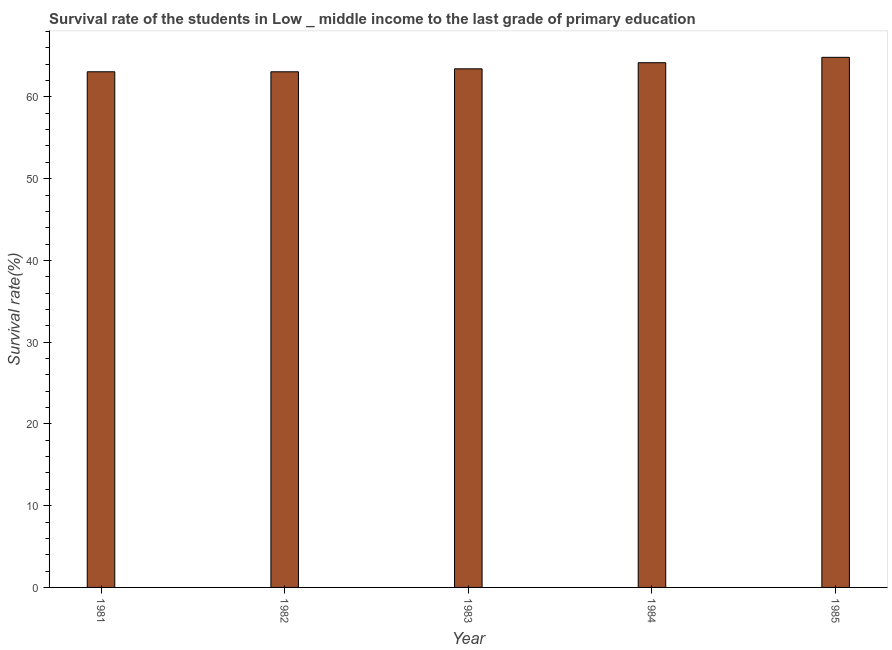Does the graph contain grids?
Offer a very short reply. No. What is the title of the graph?
Make the answer very short. Survival rate of the students in Low _ middle income to the last grade of primary education. What is the label or title of the Y-axis?
Your answer should be compact. Survival rate(%). What is the survival rate in primary education in 1982?
Make the answer very short. 63.07. Across all years, what is the maximum survival rate in primary education?
Offer a terse response. 64.84. Across all years, what is the minimum survival rate in primary education?
Provide a succinct answer. 63.07. In which year was the survival rate in primary education maximum?
Provide a short and direct response. 1985. In which year was the survival rate in primary education minimum?
Make the answer very short. 1982. What is the sum of the survival rate in primary education?
Provide a succinct answer. 318.6. What is the difference between the survival rate in primary education in 1982 and 1985?
Offer a terse response. -1.77. What is the average survival rate in primary education per year?
Your answer should be compact. 63.72. What is the median survival rate in primary education?
Offer a terse response. 63.43. Do a majority of the years between 1983 and 1981 (inclusive) have survival rate in primary education greater than 64 %?
Give a very brief answer. Yes. What is the ratio of the survival rate in primary education in 1982 to that in 1984?
Offer a terse response. 0.98. Is the difference between the survival rate in primary education in 1981 and 1982 greater than the difference between any two years?
Make the answer very short. No. What is the difference between the highest and the second highest survival rate in primary education?
Ensure brevity in your answer.  0.66. Is the sum of the survival rate in primary education in 1981 and 1982 greater than the maximum survival rate in primary education across all years?
Your answer should be very brief. Yes. What is the difference between the highest and the lowest survival rate in primary education?
Provide a succinct answer. 1.77. In how many years, is the survival rate in primary education greater than the average survival rate in primary education taken over all years?
Ensure brevity in your answer.  2. How many bars are there?
Make the answer very short. 5. How many years are there in the graph?
Keep it short and to the point. 5. What is the difference between two consecutive major ticks on the Y-axis?
Your answer should be compact. 10. Are the values on the major ticks of Y-axis written in scientific E-notation?
Your response must be concise. No. What is the Survival rate(%) in 1981?
Provide a succinct answer. 63.07. What is the Survival rate(%) in 1982?
Give a very brief answer. 63.07. What is the Survival rate(%) in 1983?
Offer a terse response. 63.43. What is the Survival rate(%) of 1984?
Provide a succinct answer. 64.18. What is the Survival rate(%) of 1985?
Offer a very short reply. 64.84. What is the difference between the Survival rate(%) in 1981 and 1982?
Your response must be concise. 0. What is the difference between the Survival rate(%) in 1981 and 1983?
Provide a succinct answer. -0.36. What is the difference between the Survival rate(%) in 1981 and 1984?
Offer a very short reply. -1.11. What is the difference between the Survival rate(%) in 1981 and 1985?
Your response must be concise. -1.77. What is the difference between the Survival rate(%) in 1982 and 1983?
Provide a succinct answer. -0.36. What is the difference between the Survival rate(%) in 1982 and 1984?
Your response must be concise. -1.11. What is the difference between the Survival rate(%) in 1982 and 1985?
Make the answer very short. -1.77. What is the difference between the Survival rate(%) in 1983 and 1984?
Provide a short and direct response. -0.75. What is the difference between the Survival rate(%) in 1983 and 1985?
Offer a terse response. -1.41. What is the difference between the Survival rate(%) in 1984 and 1985?
Provide a succinct answer. -0.66. What is the ratio of the Survival rate(%) in 1981 to that in 1984?
Make the answer very short. 0.98. What is the ratio of the Survival rate(%) in 1982 to that in 1984?
Offer a very short reply. 0.98. What is the ratio of the Survival rate(%) in 1982 to that in 1985?
Provide a succinct answer. 0.97. 